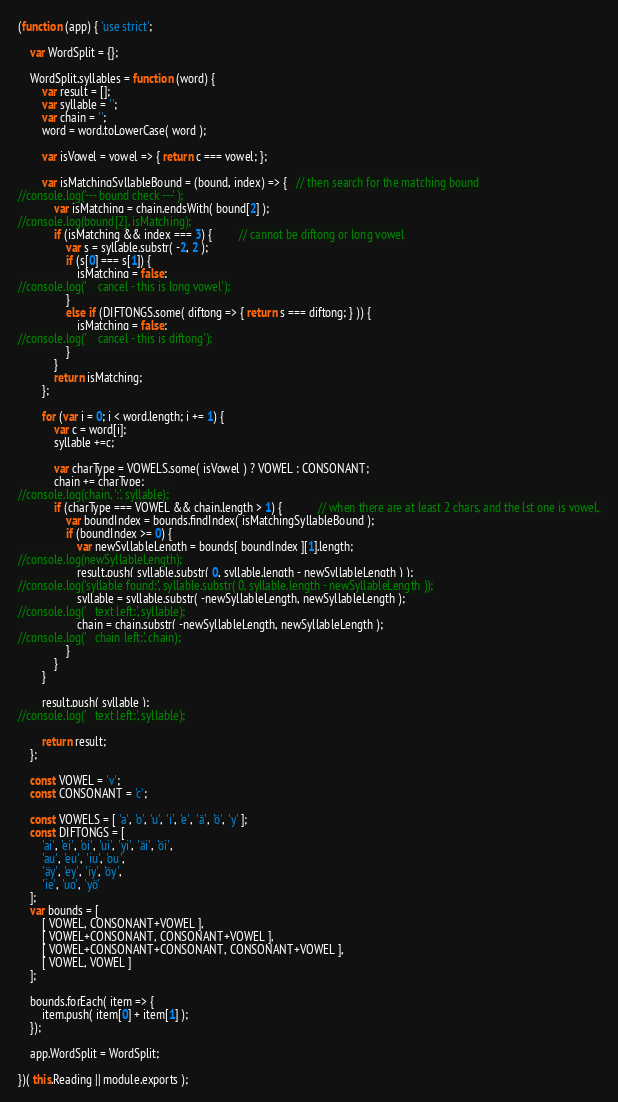<code> <loc_0><loc_0><loc_500><loc_500><_JavaScript_>(function (app) { 'use strict';

    var WordSplit = {};

    WordSplit.syllables = function (word) {
        var result = [];
        var syllable = '';
        var chain = '';
        word = word.toLowerCase( word );

        var isVowel = vowel => { return c === vowel; };

        var isMatchingSyllableBound = (bound, index) => {   // then search for the matching bound
//console.log('--- bound check ---' );
            var isMatching = chain.endsWith( bound[2] );
//console.log(bound[2], isMatching);
            if (isMatching && index === 3) {         // cannot be diftong or long vowel
                var s = syllable.substr( -2, 2 );
                if (s[0] === s[1]) {
                    isMatching = false;
//console.log('    cancel - this is long vowel');
                }
                else if (DIFTONGS.some( diftong => { return s === diftong; } )) {
                    isMatching = false;
//console.log('    cancel - this is diftong');
                }
            }
            return isMatching;
        };

        for (var i = 0; i < word.length; i += 1) {
            var c = word[i];
            syllable +=c;

            var charType = VOWELS.some( isVowel ) ? VOWEL : CONSONANT;
            chain += charType;
//console.log(chain, ':', syllable);
            if (charType === VOWEL && chain.length > 1) {            // when there are at least 2 chars, and the lst one is vowel,
                var boundIndex = bounds.findIndex( isMatchingSyllableBound );
                if (boundIndex >= 0) {
                    var newSyllableLength = bounds[ boundIndex ][1].length;
//console.log(newSyllableLength);
                    result.push( syllable.substr( 0, syllable.length - newSyllableLength ) );
//console.log('syllable found:', syllable.substr( 0, syllable.length - newSyllableLength ));
                    syllable = syllable.substr( -newSyllableLength, newSyllableLength );
//console.log('   text left:', syllable);
                    chain = chain.substr( -newSyllableLength, newSyllableLength );
//console.log('   chain left:', chain);
                }
            }
        }
        
        result.push( syllable );
//console.log('   text left:', syllable);

        return result;
    };

    const VOWEL = 'v';
    const CONSONANT = 'c';

    const VOWELS = [ 'a', 'o', 'u', 'i', 'e', 'ä', 'ö', 'y' ];
    const DIFTONGS = [
        'ai', 'ei', 'oi', 'ui', 'yi', 'äi', 'öi', 
        'au', 'eu', 'iu', 'ou',
        'äy', 'ey', 'iy', 'öy',
        'ie', 'uo', 'yö'
    ];
    var bounds = [
        [ VOWEL, CONSONANT+VOWEL ],
        [ VOWEL+CONSONANT, CONSONANT+VOWEL ],
        [ VOWEL+CONSONANT+CONSONANT, CONSONANT+VOWEL ],
        [ VOWEL, VOWEL ]
    ];

    bounds.forEach( item => {
        item.push( item[0] + item[1] );
    });

    app.WordSplit = WordSplit;
    
})( this.Reading || module.exports );
</code> 